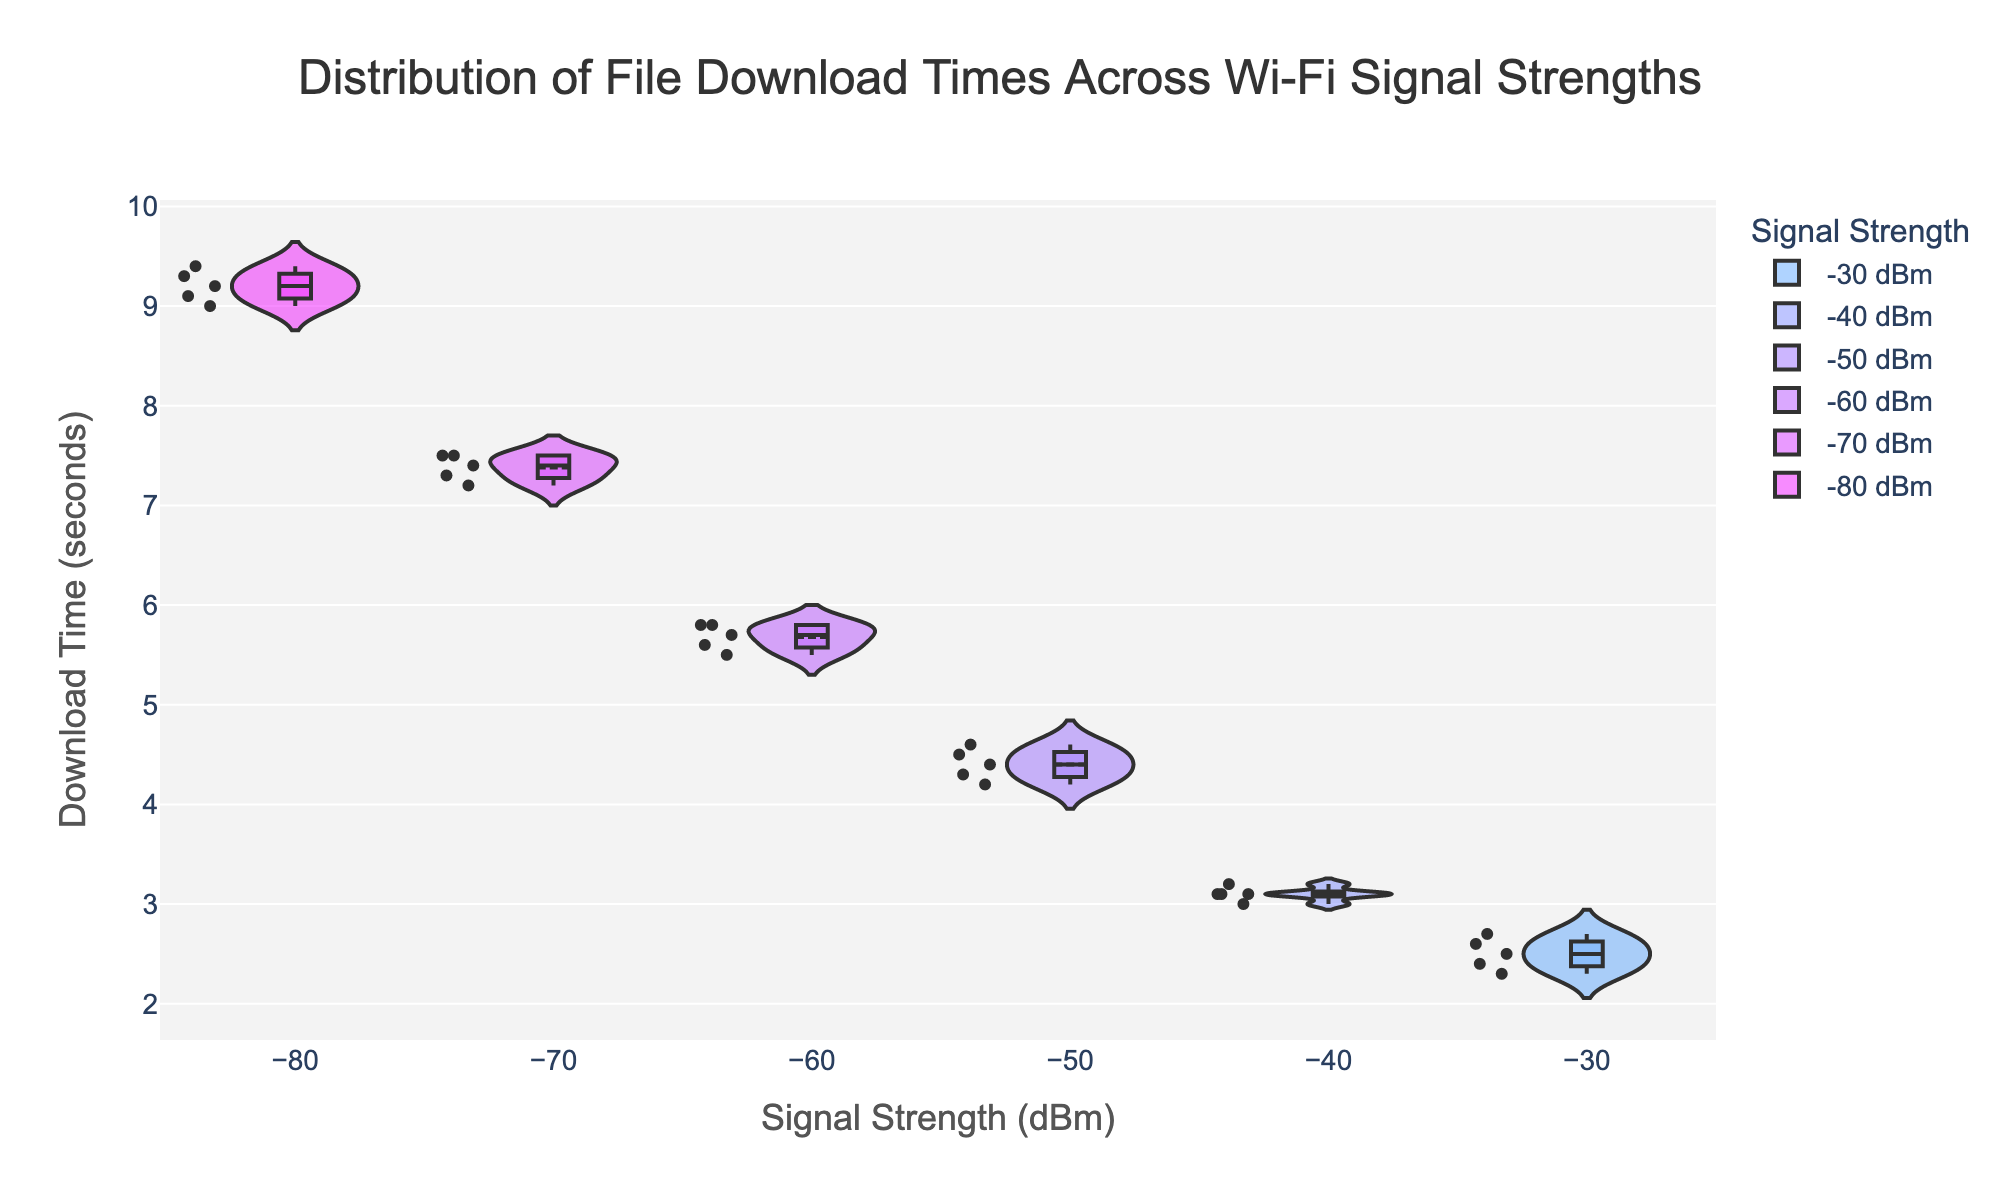What is the title of the plot? The title of the plot is usually displayed at the top of the figure. Here, the title provides an overview of what the plot represents.
Answer: Distribution of File Download Times Across Wi-Fi Signal Strengths What does the x-axis represent? The x-axis, which is usually labeled near the bottom of the plot, indicates the different categories or values. In this case, it shows the signal strengths in dBm.
Answer: Signal Strength (dBm) What is the y-axis measuring? The y-axis, typically labeled on the left side of the plot, measures the dependent variable or the values being analyzed. Here it measures file download times in seconds.
Answer: Download Time (seconds) Which signal strength category has the widest spread of download times? To determine the category with the widest spread, look for the violin plot where the width of the data distribution is the largest. This signifies more variability in the data.
Answer: -80 dBm Which signal strength has the lowest mean download time? The mean download time for each category is usually represented by a line within each violin plot. Identify the category with the lowest position of this mean line.
Answer: -30 dBm How does the median download time change as signal strength decreases? The median download time is often indicated by a central box line in each violin plot. Observing how this line shifts across categories will show the change.
Answer: It increases as signal strength decreases Which signal strength categories have noticeable outliers in their download times? Outliers can be identified by points that are isolated from the rest of the data distribution within the violin plot. Look for outliers in each category.
Answer: -30 dBm, -80 dBm Compare the download times at -50 dBm and -60 dBm and determine which is higher. Comparing the central tendency (mean or median) of the violin plots for -50 dBm and -60 dBm will indicate which has higher download times.
Answer: -60 dBm What do the colors of the violin plots represent? Colors in the plot usually help to differentiate between categories or show specific attributes. Here, the colors likely correlate with signal strength values.
Answer: Signal Strength (dBm) Is there a noticeable trend in download times as the signal strength gets weaker? Examine the general pattern of the means and medians across the categories going from stronger to weaker signal strengths to identify any trends.
Answer: Yes, download times increase with weaker signal strength 